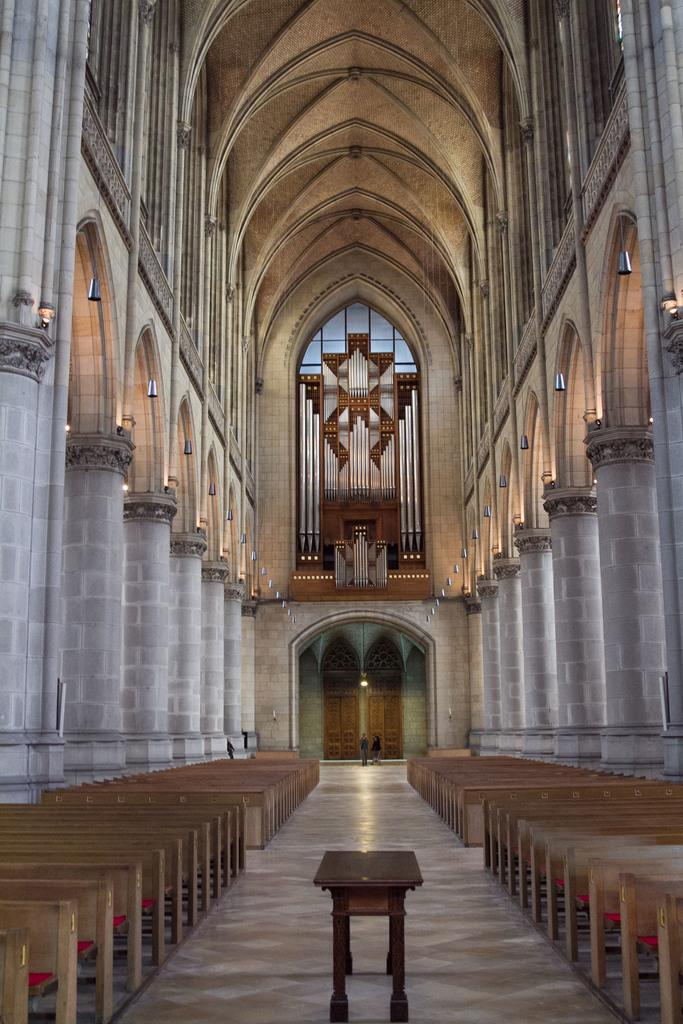What type of landscape is depicted at the bottom of the image? There are beaches at the bottom of the image. What architectural feature can be seen in the middle of the image? There are pillars in the middle of the image. What structure is visible at the top of the image? There is a roof visible at the top of the image. What type of business partnership is being formed in the image? There is no indication of a business partnership or any people in the image; it features beaches, pillars, and a roof. How does the connection between the pillars support the roof in the image? The image does not show the connection between the pillars and the roof, so it is not possible to determine how they support each other. 